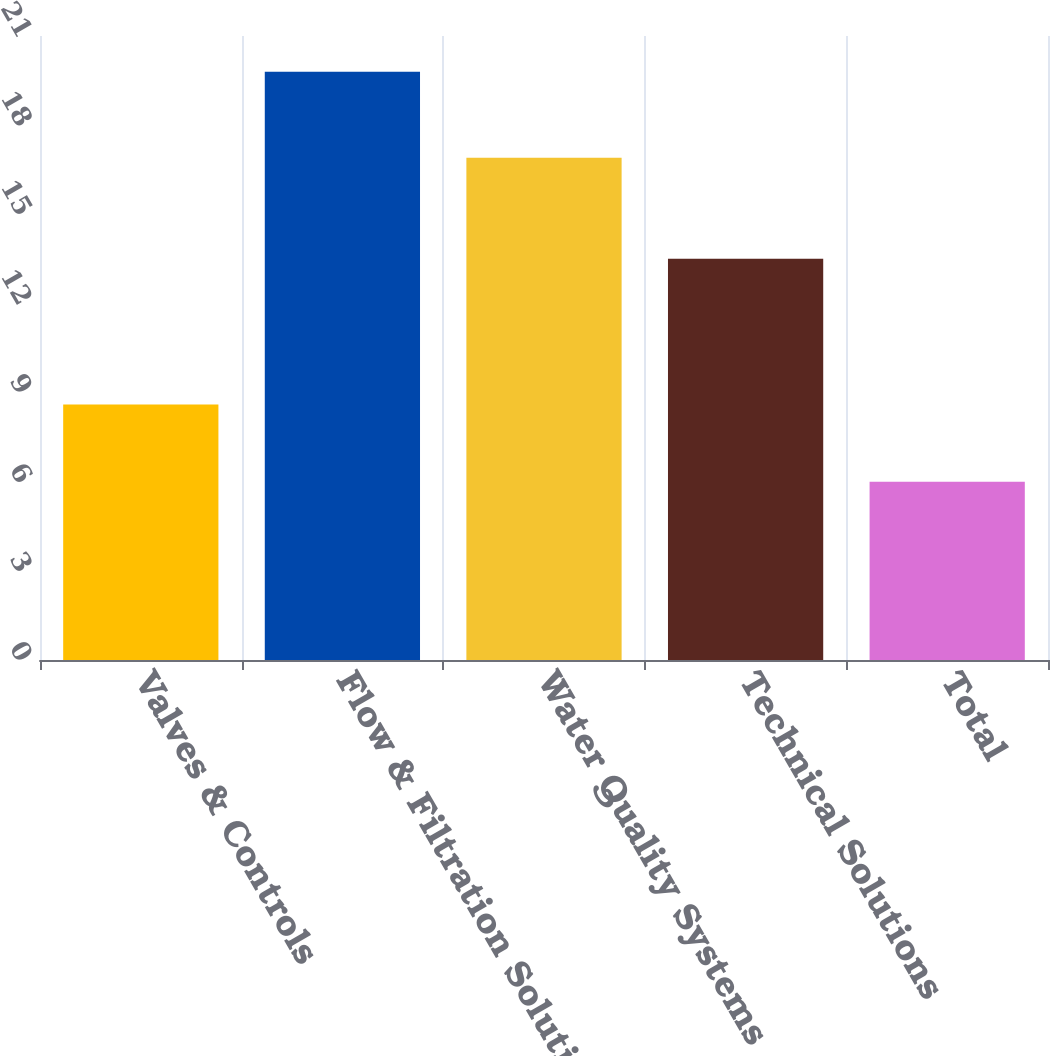Convert chart. <chart><loc_0><loc_0><loc_500><loc_500><bar_chart><fcel>Valves & Controls<fcel>Flow & Filtration Solutions<fcel>Water Quality Systems<fcel>Technical Solutions<fcel>Total<nl><fcel>8.6<fcel>19.8<fcel>16.9<fcel>13.5<fcel>6<nl></chart> 